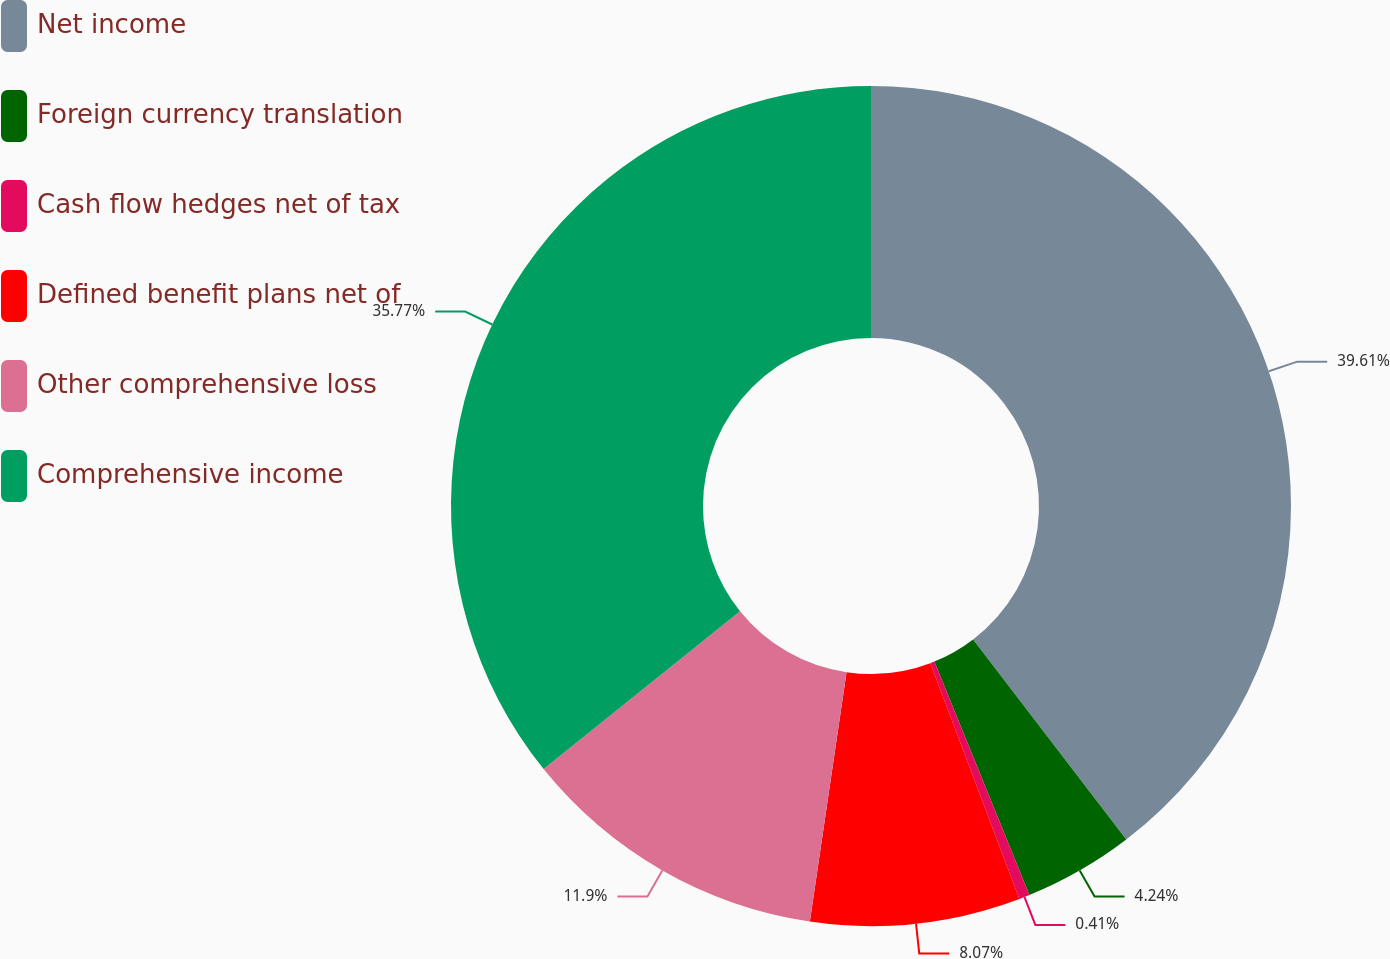<chart> <loc_0><loc_0><loc_500><loc_500><pie_chart><fcel>Net income<fcel>Foreign currency translation<fcel>Cash flow hedges net of tax<fcel>Defined benefit plans net of<fcel>Other comprehensive loss<fcel>Comprehensive income<nl><fcel>39.6%<fcel>4.24%<fcel>0.41%<fcel>8.07%<fcel>11.9%<fcel>35.77%<nl></chart> 